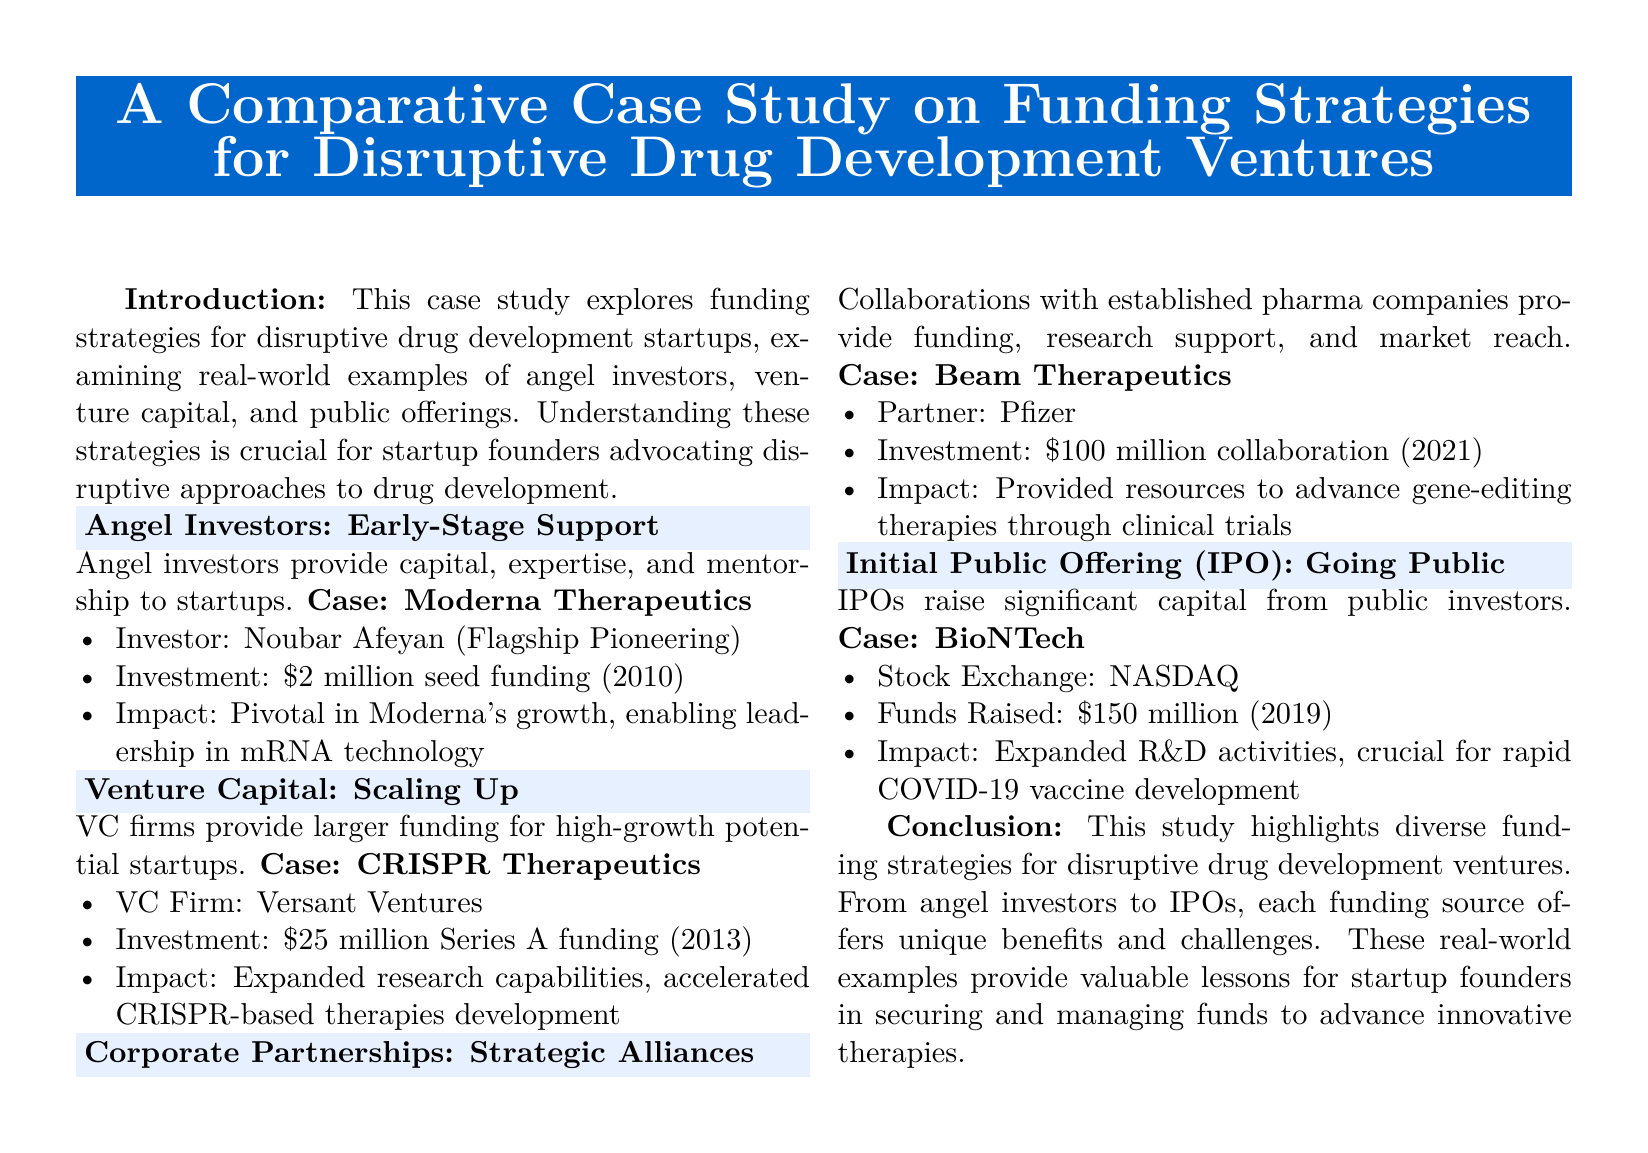What is the primary focus of this case study? The primary focus is on funding strategies for disruptive drug development startups.
Answer: funding strategies for disruptive drug development startups Who was the angel investor for Moderna Therapeutics? The document specifies Noubar Afeyan as the angel investor for Moderna Therapeutics.
Answer: Noubar Afeyan How much was the Series A funding for CRISPR Therapeutics? The document states that the Series A funding for CRISPR Therapeutics was 25 million dollars.
Answer: 25 million Which corporate partner did Beam Therapeutics collaborate with? The document indicates that Beam Therapeutics collaborated with Pfizer.
Answer: Pfizer What year did BioNTech have its IPO? The IPO year for BioNTech is identified as 2019 in the document.
Answer: 2019 What impact did the investment from angel investors have on Moderna? The investment was pivotal in Moderna's growth, enabling leadership in mRNA technology.
Answer: pivotal in Moderna's growth What is a key benefit of venture capital mentioned in the document? The document suggests that VC firms provide larger funding for high-growth potential startups.
Answer: larger funding for high-growth potential startups How much collaboration funding did Beam Therapeutics receive? The funding for the collaboration with Pfizer was 100 million dollars.
Answer: 100 million What type of document is presented here? This document is identified as a case study.
Answer: case study 